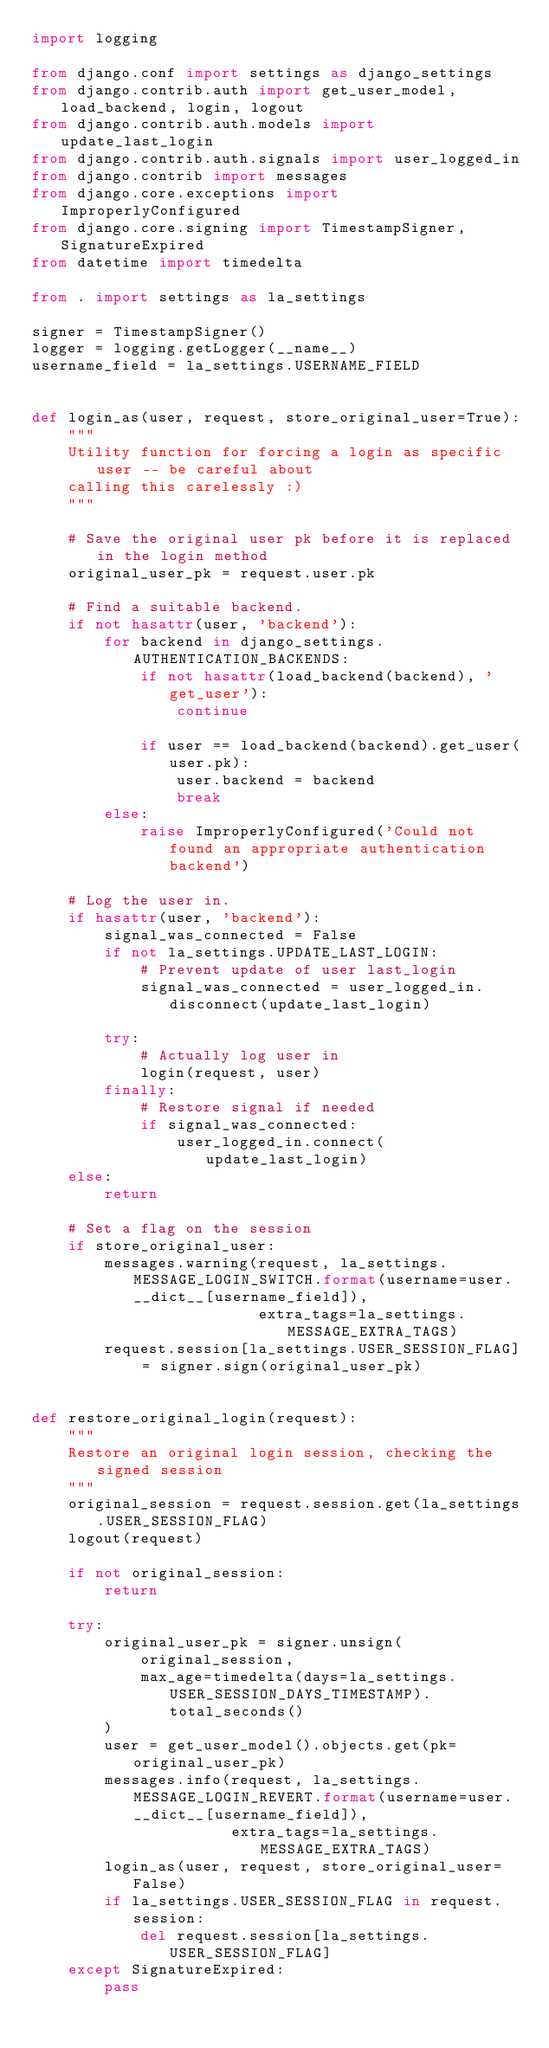Convert code to text. <code><loc_0><loc_0><loc_500><loc_500><_Python_>import logging

from django.conf import settings as django_settings
from django.contrib.auth import get_user_model, load_backend, login, logout
from django.contrib.auth.models import update_last_login
from django.contrib.auth.signals import user_logged_in
from django.contrib import messages
from django.core.exceptions import ImproperlyConfigured
from django.core.signing import TimestampSigner, SignatureExpired
from datetime import timedelta

from . import settings as la_settings

signer = TimestampSigner()
logger = logging.getLogger(__name__)
username_field = la_settings.USERNAME_FIELD


def login_as(user, request, store_original_user=True):
    """
    Utility function for forcing a login as specific user -- be careful about
    calling this carelessly :)
    """

    # Save the original user pk before it is replaced in the login method
    original_user_pk = request.user.pk

    # Find a suitable backend.
    if not hasattr(user, 'backend'):
        for backend in django_settings.AUTHENTICATION_BACKENDS:
            if not hasattr(load_backend(backend), 'get_user'):
                continue
                
            if user == load_backend(backend).get_user(user.pk):
                user.backend = backend
                break
        else:
            raise ImproperlyConfigured('Could not found an appropriate authentication backend')

    # Log the user in.
    if hasattr(user, 'backend'):
        signal_was_connected = False
        if not la_settings.UPDATE_LAST_LOGIN:
            # Prevent update of user last_login
            signal_was_connected = user_logged_in.disconnect(update_last_login)

        try:
            # Actually log user in
            login(request, user)
        finally:
            # Restore signal if needed
            if signal_was_connected:
                user_logged_in.connect(update_last_login)
    else:
        return

    # Set a flag on the session
    if store_original_user:
        messages.warning(request, la_settings.MESSAGE_LOGIN_SWITCH.format(username=user.__dict__[username_field]),
                         extra_tags=la_settings.MESSAGE_EXTRA_TAGS)
        request.session[la_settings.USER_SESSION_FLAG] = signer.sign(original_user_pk)


def restore_original_login(request):
    """
    Restore an original login session, checking the signed session
    """
    original_session = request.session.get(la_settings.USER_SESSION_FLAG)
    logout(request)

    if not original_session:
        return

    try:
        original_user_pk = signer.unsign(
            original_session,
            max_age=timedelta(days=la_settings.USER_SESSION_DAYS_TIMESTAMP).total_seconds()
        )
        user = get_user_model().objects.get(pk=original_user_pk)
        messages.info(request, la_settings.MESSAGE_LOGIN_REVERT.format(username=user.__dict__[username_field]),
                      extra_tags=la_settings.MESSAGE_EXTRA_TAGS)
        login_as(user, request, store_original_user=False)
        if la_settings.USER_SESSION_FLAG in request.session:
            del request.session[la_settings.USER_SESSION_FLAG]
    except SignatureExpired:
        pass
</code> 